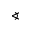Convert formula to latex. <formula><loc_0><loc_0><loc_500><loc_500>^ { h } e r i c a l a n g l e</formula> 